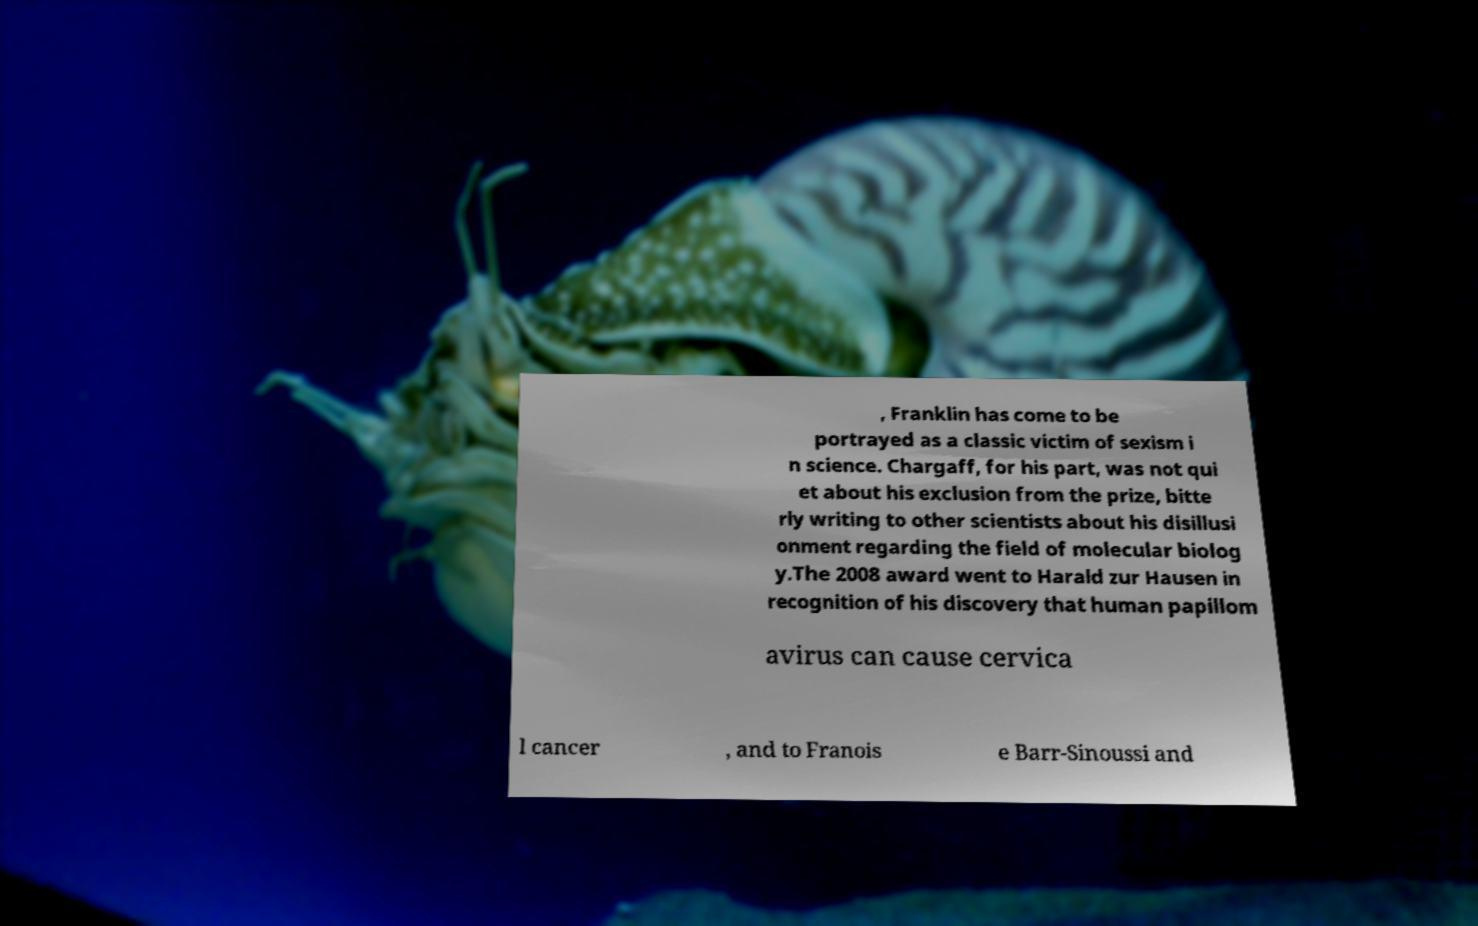There's text embedded in this image that I need extracted. Can you transcribe it verbatim? , Franklin has come to be portrayed as a classic victim of sexism i n science. Chargaff, for his part, was not qui et about his exclusion from the prize, bitte rly writing to other scientists about his disillusi onment regarding the field of molecular biolog y.The 2008 award went to Harald zur Hausen in recognition of his discovery that human papillom avirus can cause cervica l cancer , and to Franois e Barr-Sinoussi and 